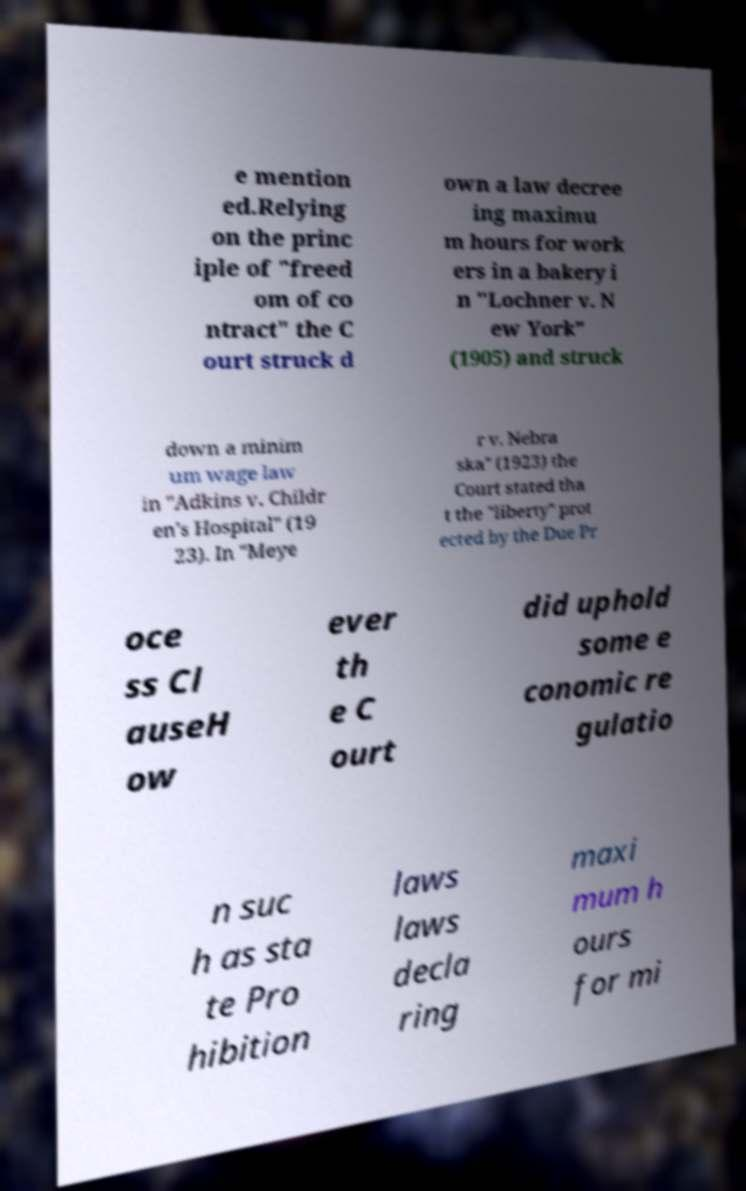What messages or text are displayed in this image? I need them in a readable, typed format. e mention ed.Relying on the princ iple of "freed om of co ntract" the C ourt struck d own a law decree ing maximu m hours for work ers in a bakery i n "Lochner v. N ew York" (1905) and struck down a minim um wage law in "Adkins v. Childr en's Hospital" (19 23). In "Meye r v. Nebra ska" (1923) the Court stated tha t the "liberty" prot ected by the Due Pr oce ss Cl auseH ow ever th e C ourt did uphold some e conomic re gulatio n suc h as sta te Pro hibition laws laws decla ring maxi mum h ours for mi 